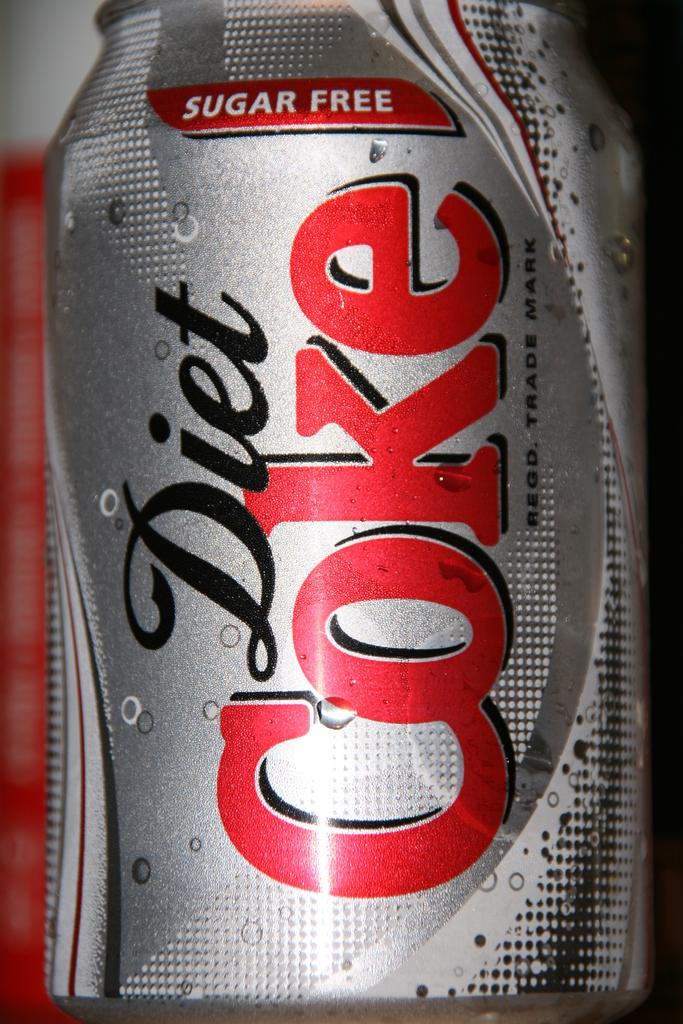<image>
Share a concise interpretation of the image provided. a diet coke that is gray in color 